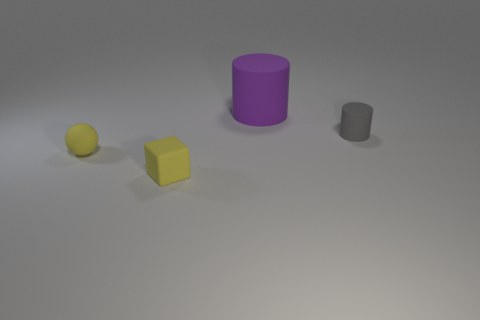Add 2 small gray matte things. How many objects exist? 6 Subtract all balls. How many objects are left? 3 Subtract all brown cubes. Subtract all cyan balls. How many cubes are left? 1 Subtract all tiny gray rubber things. Subtract all yellow rubber things. How many objects are left? 1 Add 4 small yellow objects. How many small yellow objects are left? 6 Add 4 small gray matte things. How many small gray matte things exist? 5 Subtract 1 purple cylinders. How many objects are left? 3 